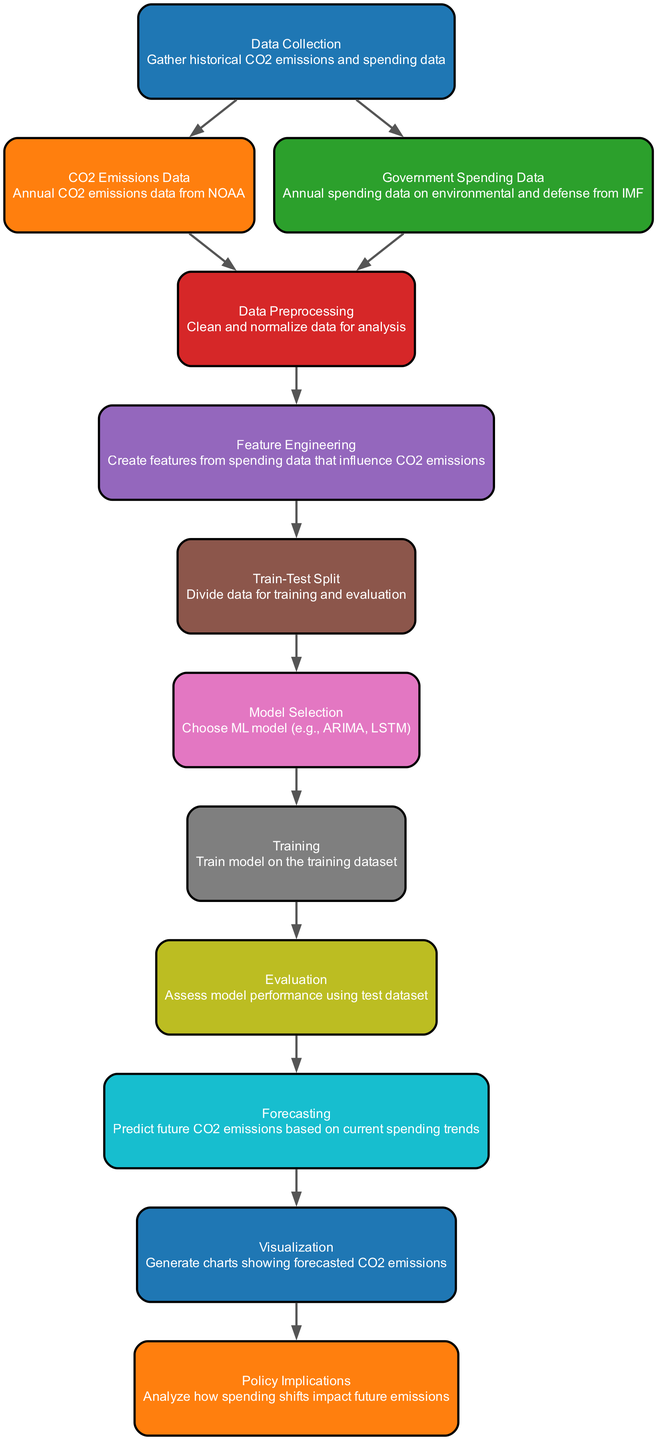What is the first step in the pipeline? The first step in the pipeline is "Data Collection," which is indicated as the starting node in the diagram.
Answer: Data Collection How many nodes are in the diagram? By counting each unique node listed in the data structure, we find there are 12 nodes.
Answer: 12 What type of data do we collect for CO2 emissions? The CO2 emissions data is from NOAA, which is specified in the "CO2 Emissions Data" node.
Answer: NOAA Which two types of data are gathered during data collection? The diagram specifies that both CO2 emissions data and government spending data are collected during the data collection phase.
Answer: CO2 emissions data and government spending data What step comes after data preprocessing? According to the flow of the diagram, the step that follows "Data Preprocessing" is "Feature Engineering."
Answer: Feature Engineering Which model selection options might be considered in this pipeline? The "Model Selection" node suggests considering models like ARIMA and LSTM as options for analysis.
Answer: ARIMA, LSTM What do we assess during the evaluation phase? During the "Evaluation" phase, we assess the model performance using the test dataset, as indicated in the diagram.
Answer: Model performance What is the final outcome generated from the visualization node? The "Visualization" node generates charts that display the forecasted CO2 emissions.
Answer: Forecasted CO2 emissions charts What are the policy implications based on the diagram? The final node, "Policy Implications," suggests analyzing how shifts in government spending impact future emissions.
Answer: Impact of spending shifts on future emissions 